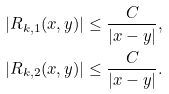Convert formula to latex. <formula><loc_0><loc_0><loc_500><loc_500>| R _ { k , 1 } ( x , y ) | \leq \frac { C } { | x - y | } , \\ | R _ { k , 2 } ( x , y ) | \leq \frac { C } { | x - y | } .</formula> 